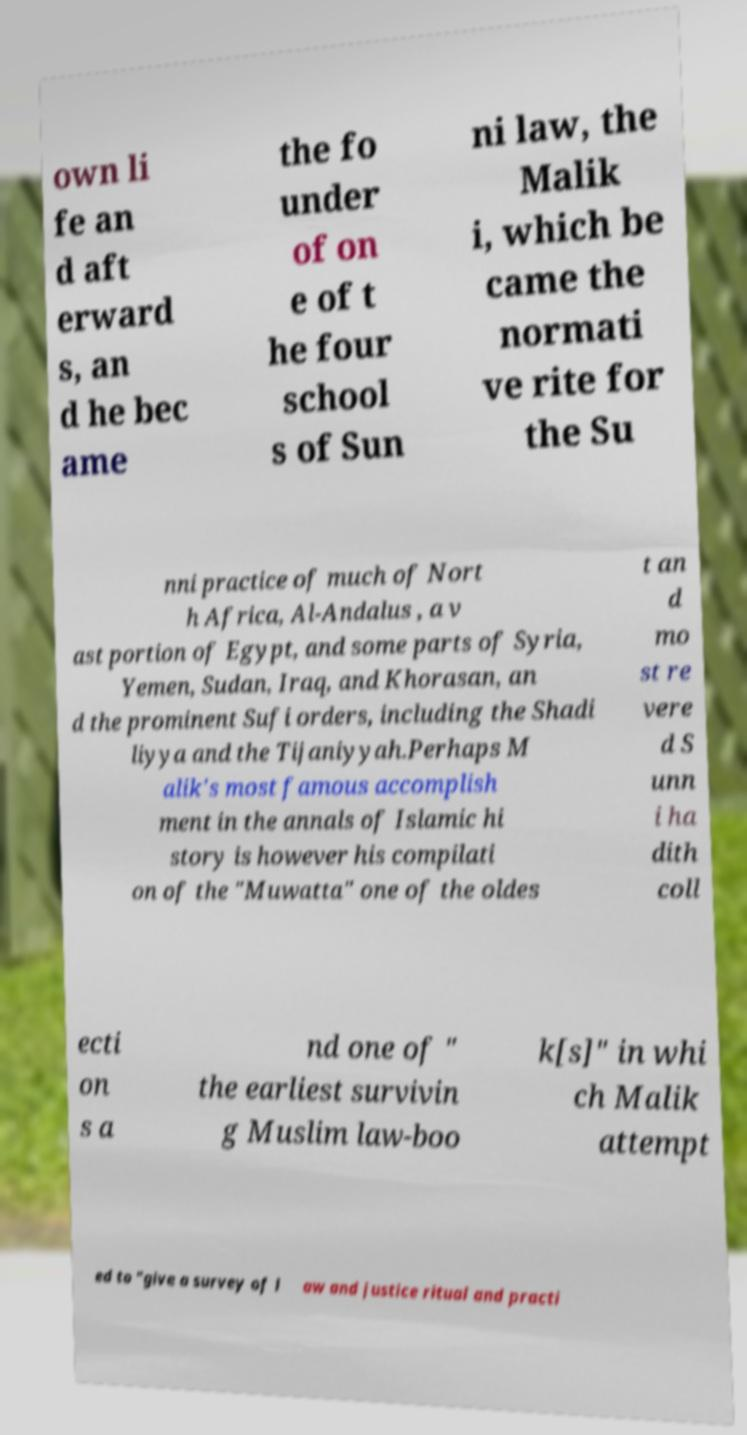There's text embedded in this image that I need extracted. Can you transcribe it verbatim? own li fe an d aft erward s, an d he bec ame the fo under of on e of t he four school s of Sun ni law, the Malik i, which be came the normati ve rite for the Su nni practice of much of Nort h Africa, Al-Andalus , a v ast portion of Egypt, and some parts of Syria, Yemen, Sudan, Iraq, and Khorasan, an d the prominent Sufi orders, including the Shadi liyya and the Tijaniyyah.Perhaps M alik's most famous accomplish ment in the annals of Islamic hi story is however his compilati on of the "Muwatta" one of the oldes t an d mo st re vere d S unn i ha dith coll ecti on s a nd one of " the earliest survivin g Muslim law-boo k[s]" in whi ch Malik attempt ed to "give a survey of l aw and justice ritual and practi 